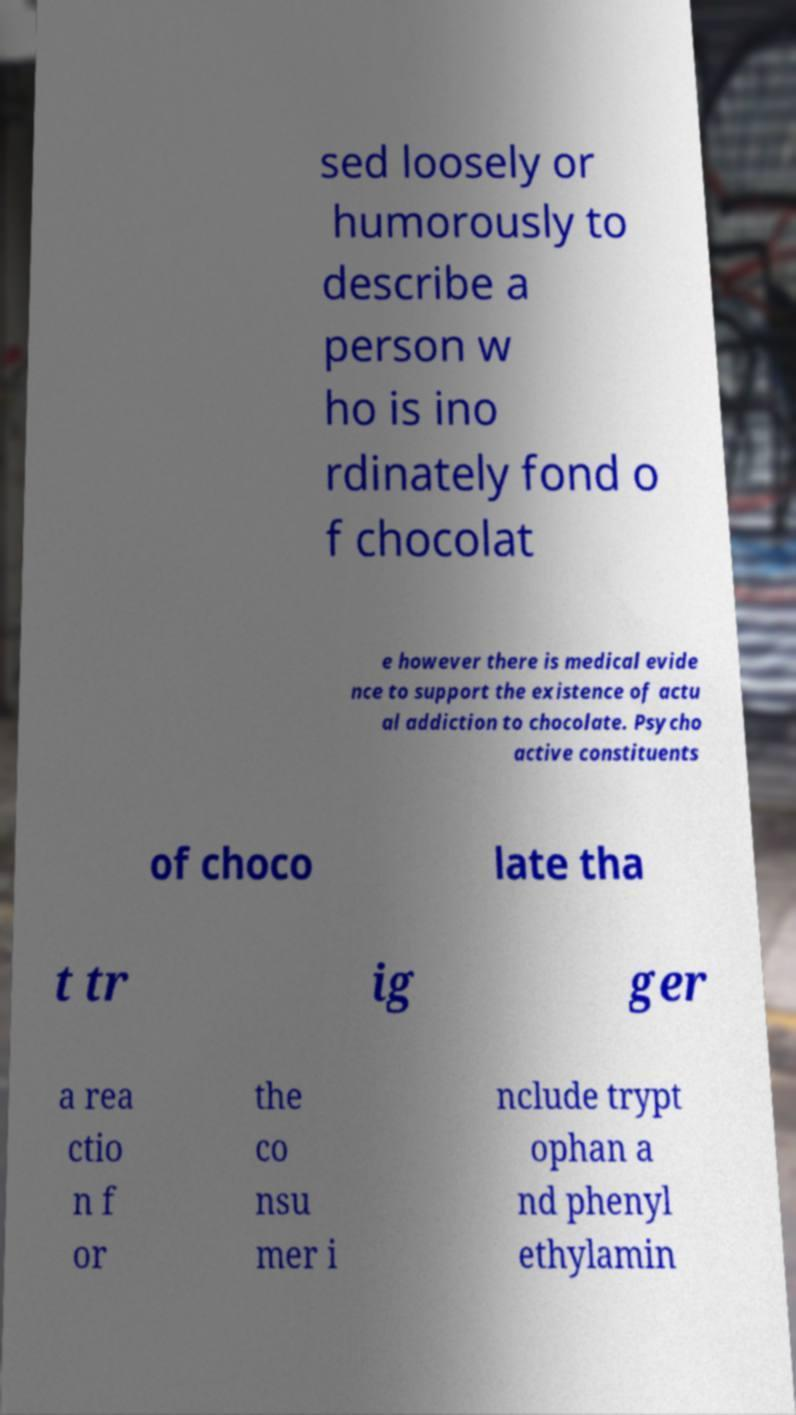There's text embedded in this image that I need extracted. Can you transcribe it verbatim? sed loosely or humorously to describe a person w ho is ino rdinately fond o f chocolat e however there is medical evide nce to support the existence of actu al addiction to chocolate. Psycho active constituents of choco late tha t tr ig ger a rea ctio n f or the co nsu mer i nclude trypt ophan a nd phenyl ethylamin 